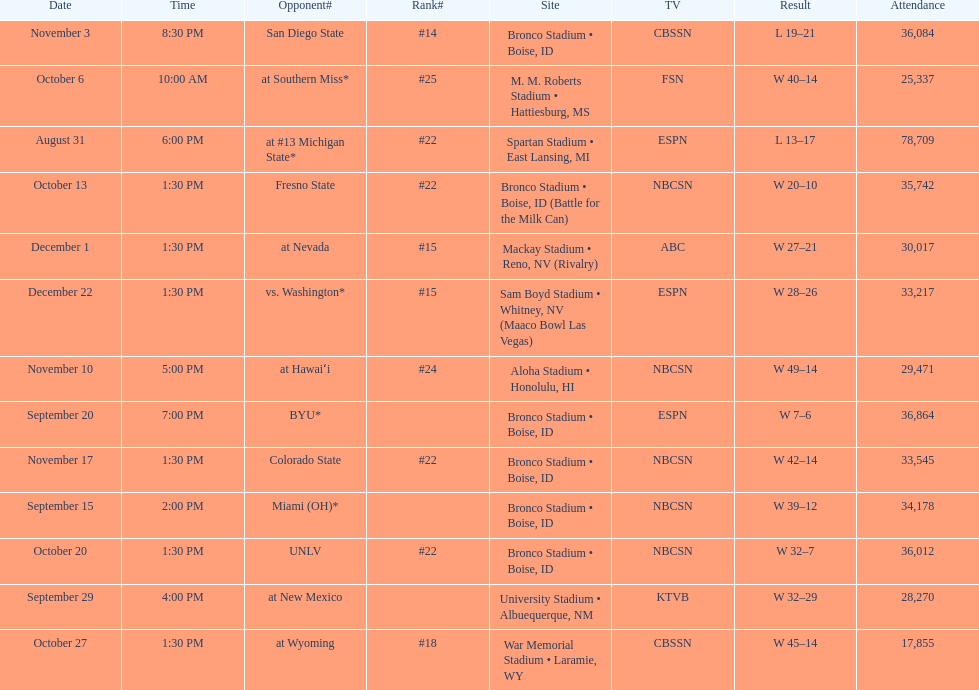What was there top ranked position of the season? #14. 